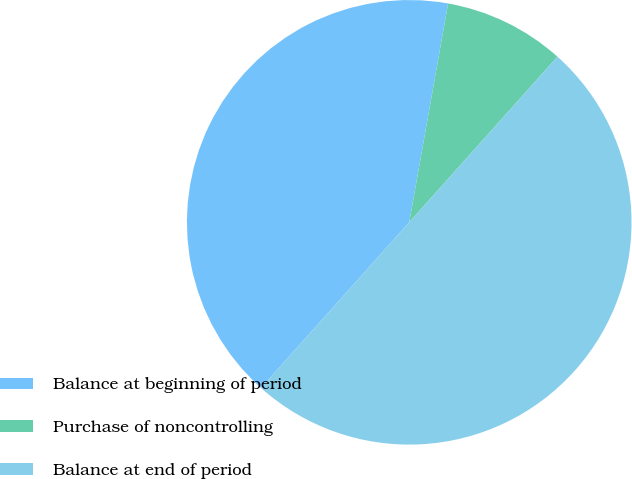Convert chart to OTSL. <chart><loc_0><loc_0><loc_500><loc_500><pie_chart><fcel>Balance at beginning of period<fcel>Purchase of noncontrolling<fcel>Balance at end of period<nl><fcel>41.18%<fcel>8.82%<fcel>50.0%<nl></chart> 